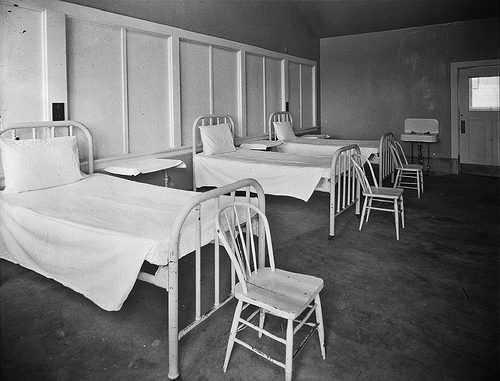This room looks like an old type of what?
A. church
B. hospital
C. prison
D. school
Answer with the option's letter from the given choices directly. B 